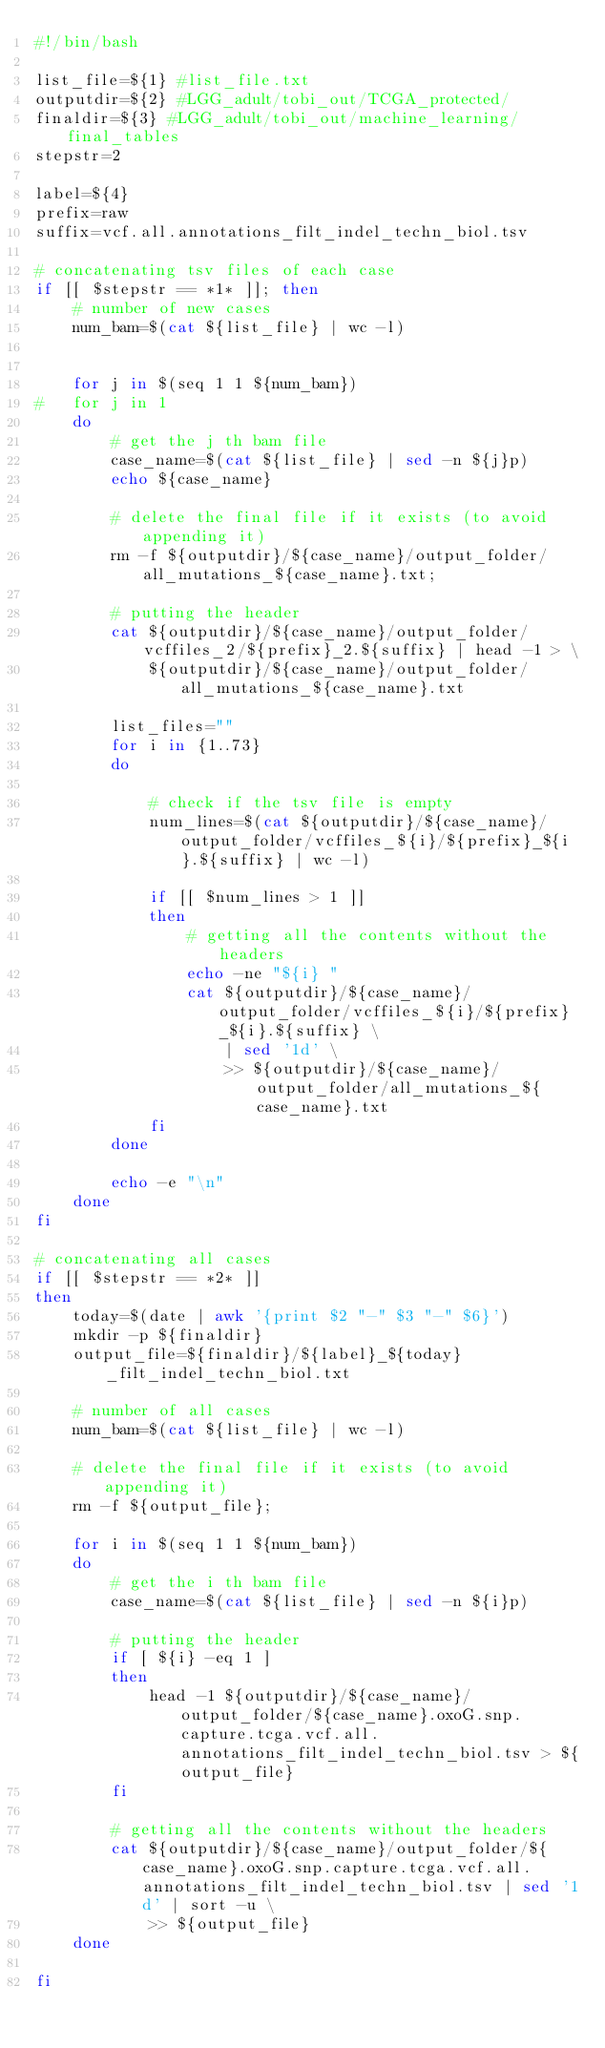Convert code to text. <code><loc_0><loc_0><loc_500><loc_500><_Bash_>#!/bin/bash

list_file=${1} #list_file.txt
outputdir=${2} #LGG_adult/tobi_out/TCGA_protected/
finaldir=${3} #LGG_adult/tobi_out/machine_learning/final_tables
stepstr=2

label=${4}
prefix=raw
suffix=vcf.all.annotations_filt_indel_techn_biol.tsv

# concatenating tsv files of each case
if [[ $stepstr == *1* ]]; then
	# number of new cases
	num_bam=$(cat ${list_file} | wc -l)
	
	
	for j in $(seq 1 1 ${num_bam})
#	for j in 1
	do
		# get the j th bam file
		case_name=$(cat ${list_file} | sed -n ${j}p)
		echo ${case_name}
		
		# delete the final file if it exists (to avoid appending it)
		rm -f ${outputdir}/${case_name}/output_folder/all_mutations_${case_name}.txt;
		
		# putting the header
		cat ${outputdir}/${case_name}/output_folder/vcffiles_2/${prefix}_2.${suffix} | head -1 > \
		    ${outputdir}/${case_name}/output_folder/all_mutations_${case_name}.txt
		
		list_files=""
		for i in {1..73}
		do
			
			# check if the tsv file is empty
			num_lines=$(cat ${outputdir}/${case_name}/output_folder/vcffiles_${i}/${prefix}_${i}.${suffix} | wc -l)

			if [[ $num_lines > 1 ]]
			then
				# getting all the contents without the headers
				echo -ne "${i} "
				cat ${outputdir}/${case_name}/output_folder/vcffiles_${i}/${prefix}_${i}.${suffix} \
					| sed '1d' \
					>> ${outputdir}/${case_name}/output_folder/all_mutations_${case_name}.txt
			fi
		done
		
		echo -e "\n"
	done
fi

# concatenating all cases
if [[ $stepstr == *2* ]]
then
	today=$(date | awk '{print $2 "-" $3 "-" $6}')
	mkdir -p ${finaldir}	
	output_file=${finaldir}/${label}_${today}_filt_indel_techn_biol.txt
	
	# number of all cases
	num_bam=$(cat ${list_file} | wc -l)
	
	# delete the final file if it exists (to avoid appending it)
	rm -f ${output_file};
	
	for i in $(seq 1 1 ${num_bam})
	do
		# get the i th bam file
		case_name=$(cat ${list_file} | sed -n ${i}p)
		
		# putting the header
		if [ ${i} -eq 1 ]
		then
			head -1 ${outputdir}/${case_name}/output_folder/${case_name}.oxoG.snp.capture.tcga.vcf.all.annotations_filt_indel_techn_biol.tsv > ${output_file}
		fi
		
		# getting all the contents without the headers
		cat ${outputdir}/${case_name}/output_folder/${case_name}.oxoG.snp.capture.tcga.vcf.all.annotations_filt_indel_techn_biol.tsv | sed '1d' | sort -u \
			>> ${output_file}
	done
	
fi


</code> 